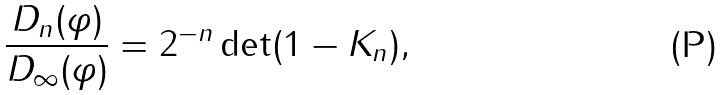Convert formula to latex. <formula><loc_0><loc_0><loc_500><loc_500>\frac { D _ { n } ( \varphi ) } { D _ { \infty } ( \varphi ) } = 2 ^ { - n } \det ( 1 - K _ { n } ) ,</formula> 